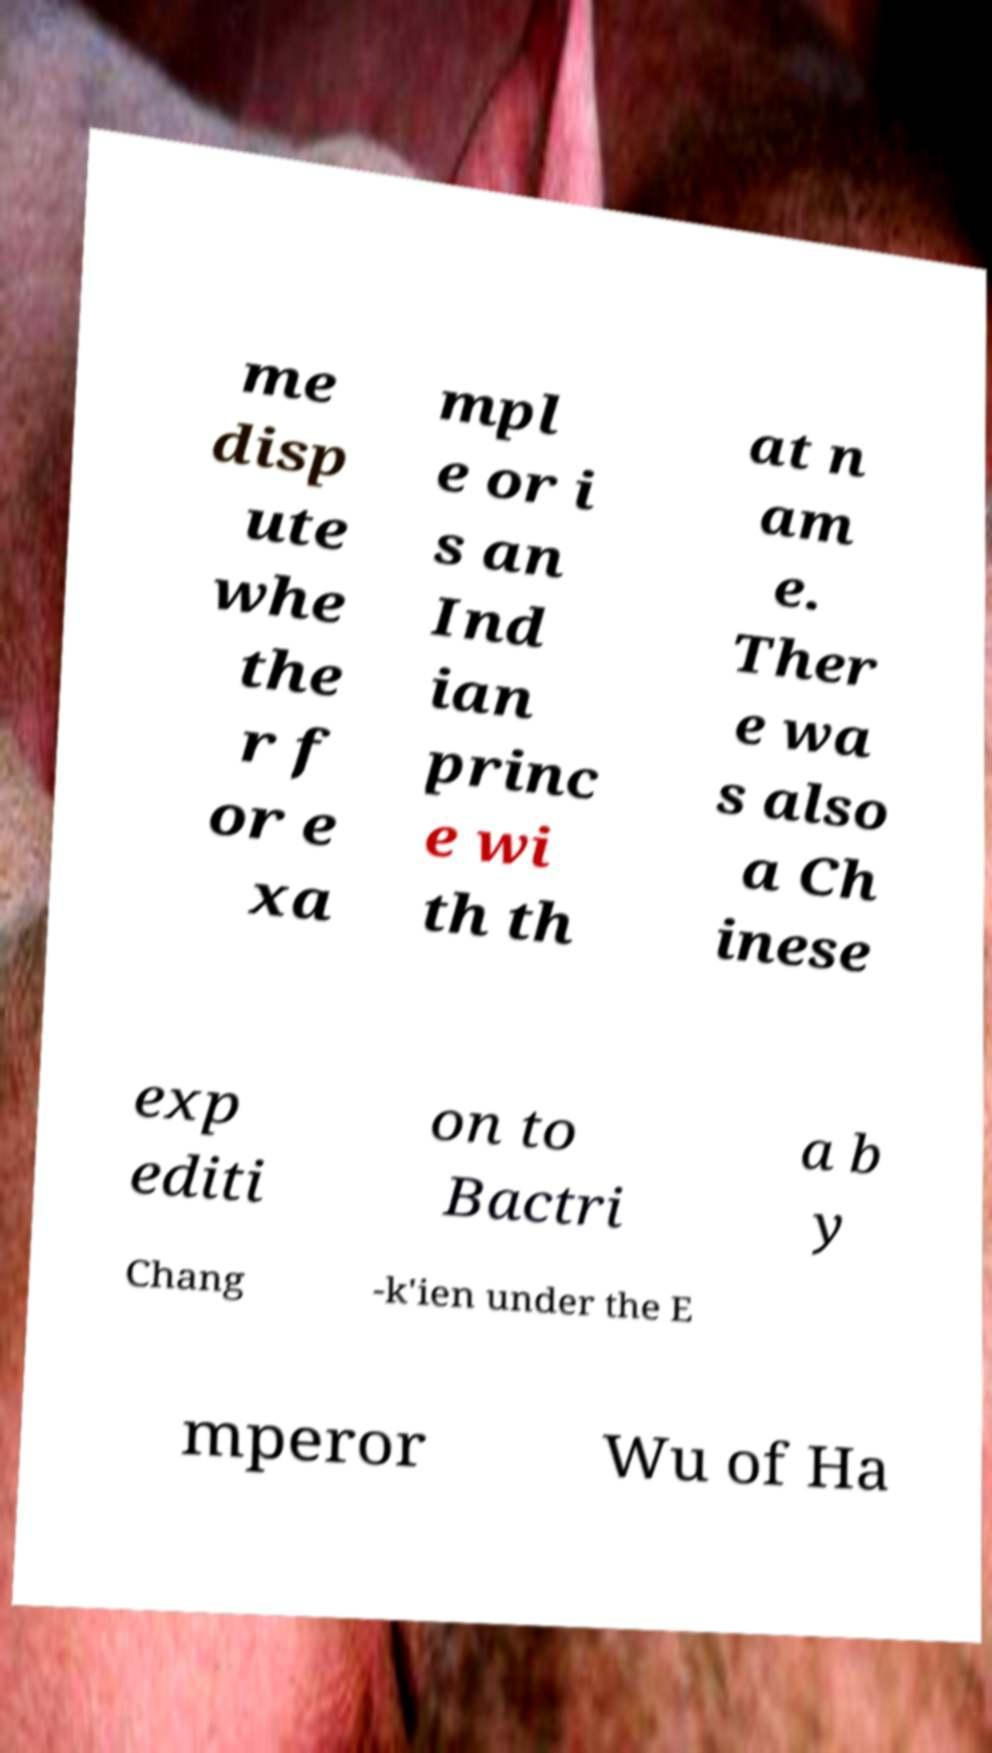For documentation purposes, I need the text within this image transcribed. Could you provide that? me disp ute whe the r f or e xa mpl e or i s an Ind ian princ e wi th th at n am e. Ther e wa s also a Ch inese exp editi on to Bactri a b y Chang -k'ien under the E mperor Wu of Ha 